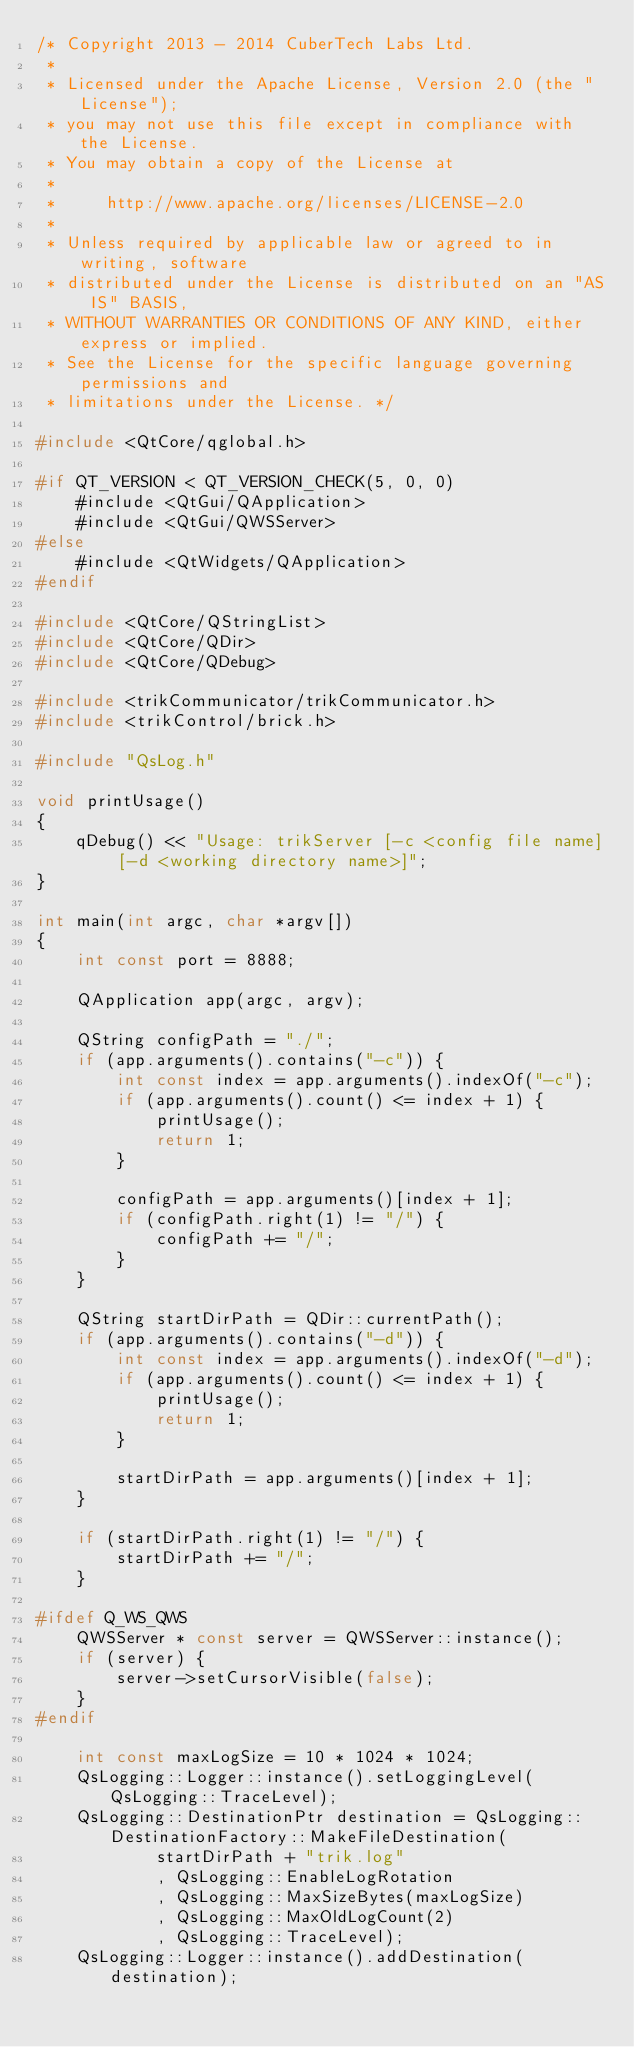Convert code to text. <code><loc_0><loc_0><loc_500><loc_500><_C++_>/* Copyright 2013 - 2014 CuberTech Labs Ltd.
 *
 * Licensed under the Apache License, Version 2.0 (the "License");
 * you may not use this file except in compliance with the License.
 * You may obtain a copy of the License at
 *
 *     http://www.apache.org/licenses/LICENSE-2.0
 *
 * Unless required by applicable law or agreed to in writing, software
 * distributed under the License is distributed on an "AS IS" BASIS,
 * WITHOUT WARRANTIES OR CONDITIONS OF ANY KIND, either express or implied.
 * See the License for the specific language governing permissions and
 * limitations under the License. */

#include <QtCore/qglobal.h>

#if QT_VERSION < QT_VERSION_CHECK(5, 0, 0)
	#include <QtGui/QApplication>
	#include <QtGui/QWSServer>
#else
	#include <QtWidgets/QApplication>
#endif

#include <QtCore/QStringList>
#include <QtCore/QDir>
#include <QtCore/QDebug>

#include <trikCommunicator/trikCommunicator.h>
#include <trikControl/brick.h>

#include "QsLog.h"

void printUsage()
{
	qDebug() << "Usage: trikServer [-c <config file name] [-d <working directory name>]";
}

int main(int argc, char *argv[])
{
	int const port = 8888;

	QApplication app(argc, argv);

	QString configPath = "./";
	if (app.arguments().contains("-c")) {
		int const index = app.arguments().indexOf("-c");
		if (app.arguments().count() <= index + 1) {
			printUsage();
			return 1;
		}

		configPath = app.arguments()[index + 1];
		if (configPath.right(1) != "/") {
			configPath += "/";
		}
	}

	QString startDirPath = QDir::currentPath();
	if (app.arguments().contains("-d")) {
		int const index = app.arguments().indexOf("-d");
		if (app.arguments().count() <= index + 1) {
			printUsage();
			return 1;
		}

		startDirPath = app.arguments()[index + 1];
	}

	if (startDirPath.right(1) != "/") {
		startDirPath += "/";
	}

#ifdef Q_WS_QWS
	QWSServer * const server = QWSServer::instance();
	if (server) {
		server->setCursorVisible(false);
	}
#endif

	int const maxLogSize = 10 * 1024 * 1024;
	QsLogging::Logger::instance().setLoggingLevel(QsLogging::TraceLevel);
	QsLogging::DestinationPtr destination = QsLogging::DestinationFactory::MakeFileDestination(
			startDirPath + "trik.log"
			, QsLogging::EnableLogRotation
			, QsLogging::MaxSizeBytes(maxLogSize)
			, QsLogging::MaxOldLogCount(2)
			, QsLogging::TraceLevel);
	QsLogging::Logger::instance().addDestination(destination);</code> 